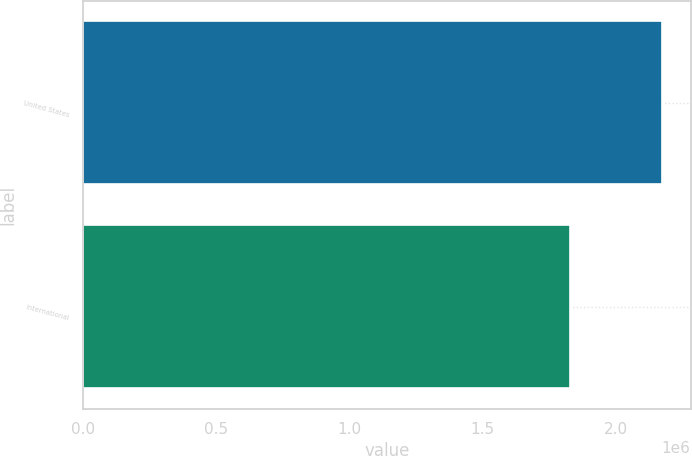<chart> <loc_0><loc_0><loc_500><loc_500><bar_chart><fcel>United States<fcel>International<nl><fcel>2.17327e+06<fcel>1.8289e+06<nl></chart> 